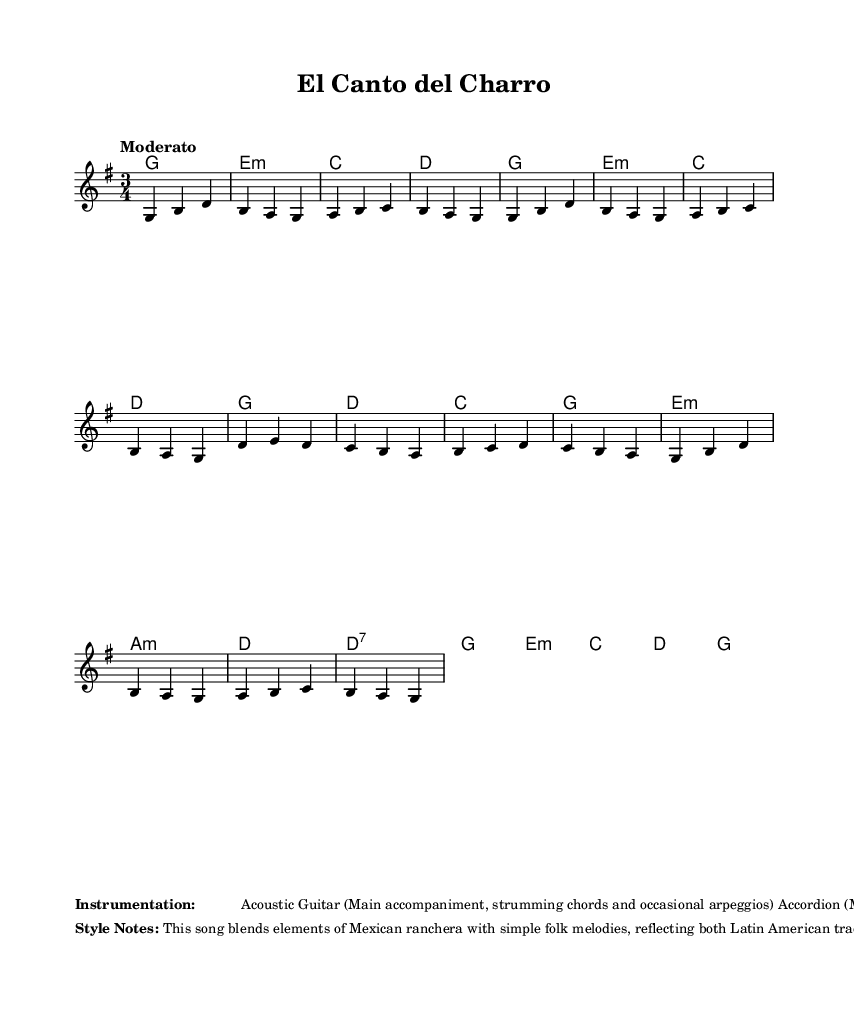What is the key signature of this music? The key signature indicates G major, which has one sharp (F#). This is inferred from the global variable defining the key signature at the beginning of the code.
Answer: G major What is the time signature of this music? The time signature is shown as 3/4 in the global variable section. This indicates that each measure contains three beats, and the quarter note gets one beat.
Answer: 3/4 What is the tempo marking of this song? The tempo marking is indicated as "Moderato", which generally suggests a moderate speed of 108-120 beats per minute. This is found in the global variable of the music code.
Answer: Moderato What instruments are used in this piece? The instrumentation listed includes Acoustic Guitar, Accordion, and Güiro. This is specified in the markup section of the code, detailing the instruments used for accompaniment and melody.
Answer: Acoustic Guitar, Accordion, Güiro What stylistic elements are present in this song? The style notes mention a blend of Mexican ranchera with folk melodies, emphasizing the humble roots of early country music. This information is provided in the markup section describing the style attributes.
Answer: Mexican ranchera, folk melodies 